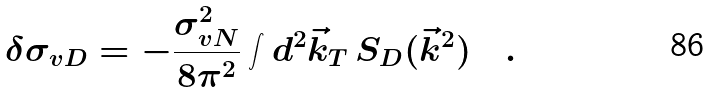Convert formula to latex. <formula><loc_0><loc_0><loc_500><loc_500>\delta \sigma _ { v D } = - \frac { \sigma _ { v N } ^ { 2 } } { 8 \pi ^ { 2 } } \int d ^ { 2 } \vec { k } _ { T } \, S _ { D } ( \vec { k } ^ { 2 } ) \quad .</formula> 